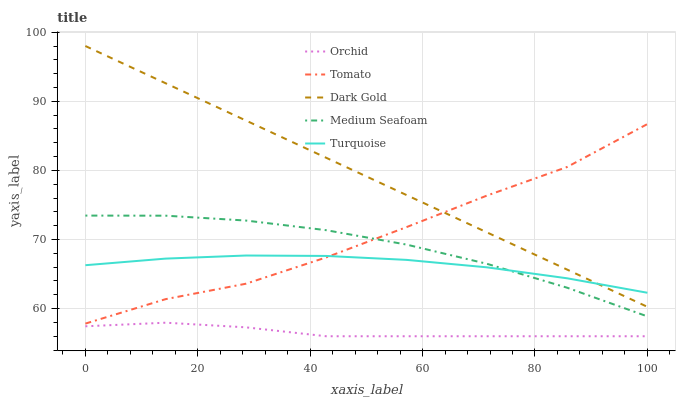Does Orchid have the minimum area under the curve?
Answer yes or no. Yes. Does Dark Gold have the maximum area under the curve?
Answer yes or no. Yes. Does Turquoise have the minimum area under the curve?
Answer yes or no. No. Does Turquoise have the maximum area under the curve?
Answer yes or no. No. Is Dark Gold the smoothest?
Answer yes or no. Yes. Is Tomato the roughest?
Answer yes or no. Yes. Is Turquoise the smoothest?
Answer yes or no. No. Is Turquoise the roughest?
Answer yes or no. No. Does Orchid have the lowest value?
Answer yes or no. Yes. Does Dark Gold have the lowest value?
Answer yes or no. No. Does Dark Gold have the highest value?
Answer yes or no. Yes. Does Turquoise have the highest value?
Answer yes or no. No. Is Orchid less than Turquoise?
Answer yes or no. Yes. Is Turquoise greater than Orchid?
Answer yes or no. Yes. Does Tomato intersect Turquoise?
Answer yes or no. Yes. Is Tomato less than Turquoise?
Answer yes or no. No. Is Tomato greater than Turquoise?
Answer yes or no. No. Does Orchid intersect Turquoise?
Answer yes or no. No. 